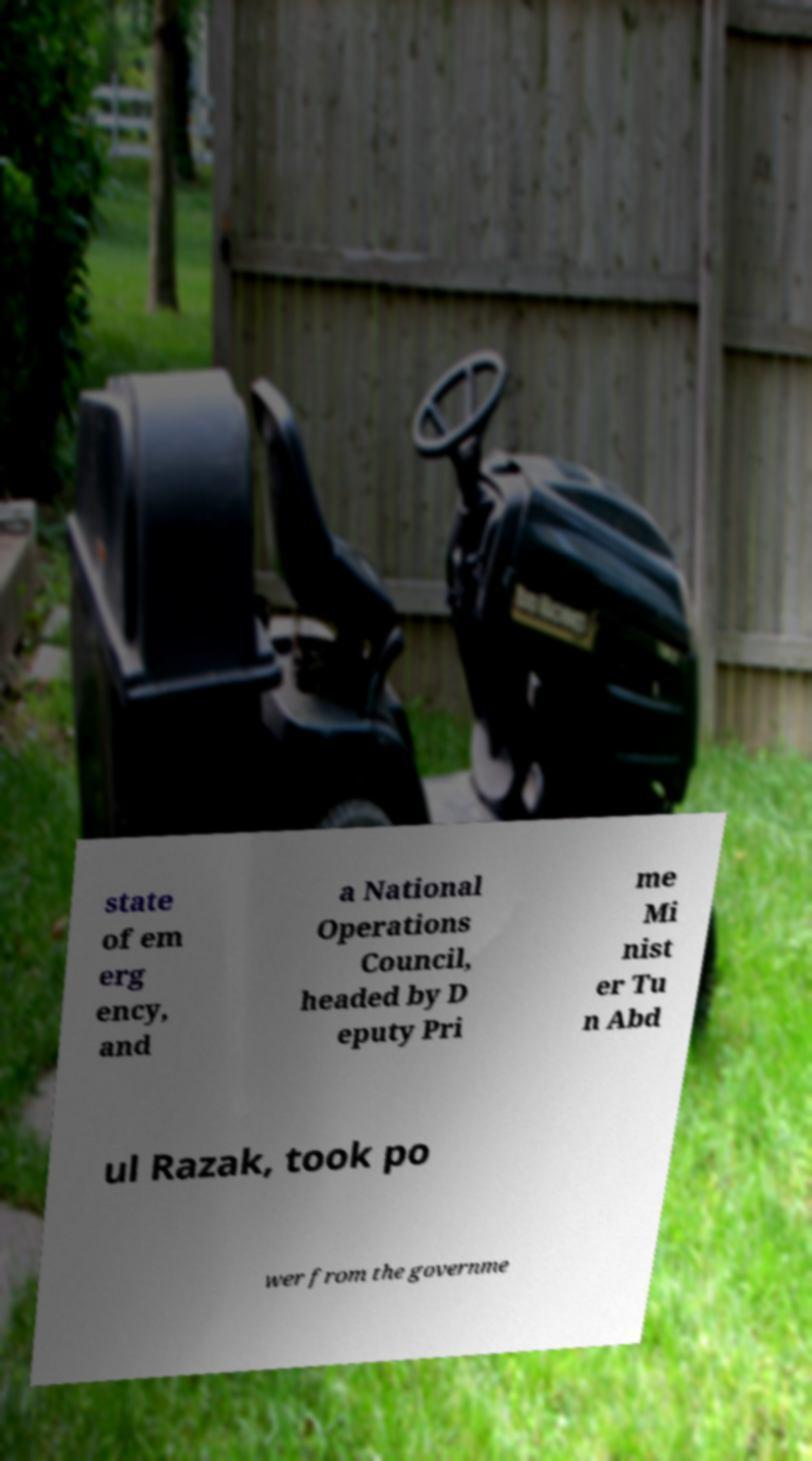There's text embedded in this image that I need extracted. Can you transcribe it verbatim? state of em erg ency, and a National Operations Council, headed by D eputy Pri me Mi nist er Tu n Abd ul Razak, took po wer from the governme 